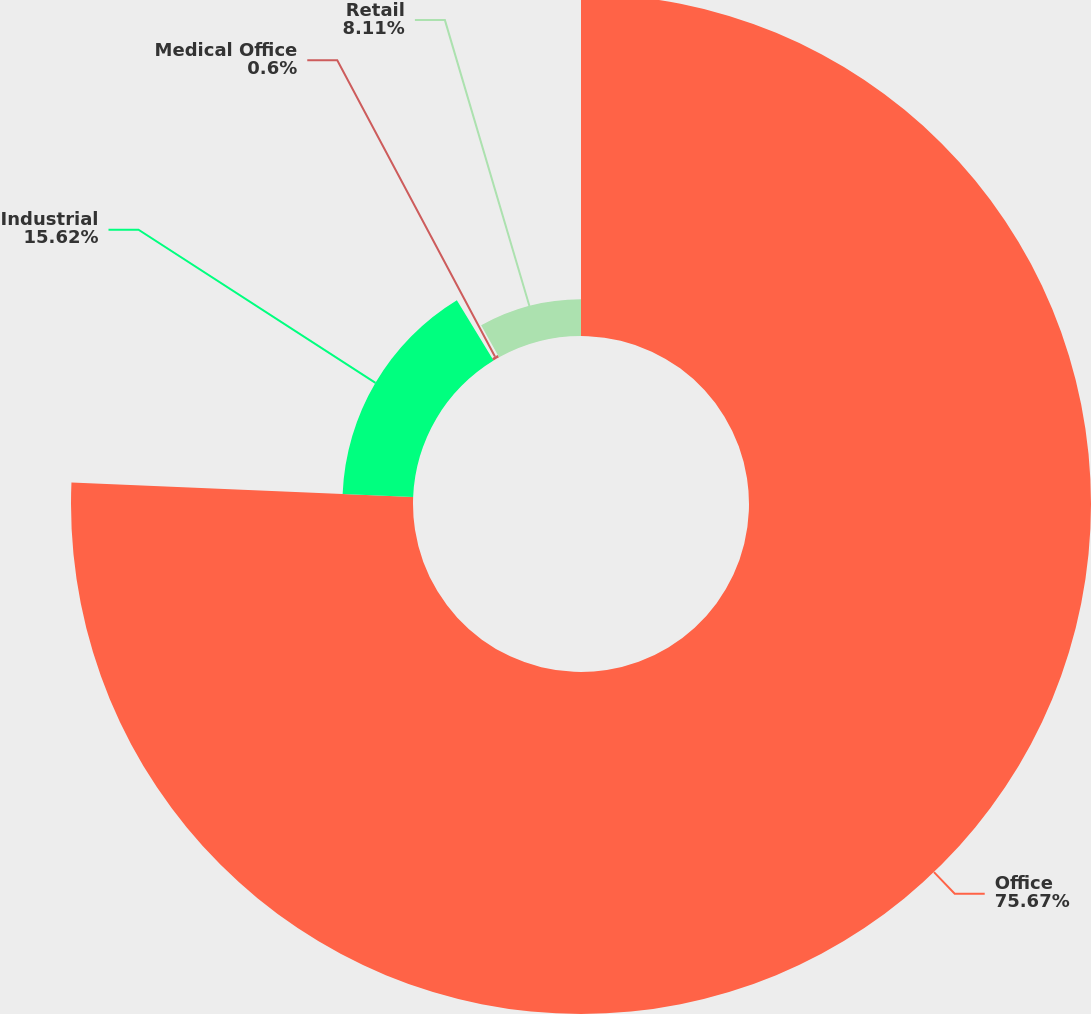Convert chart to OTSL. <chart><loc_0><loc_0><loc_500><loc_500><pie_chart><fcel>Office<fcel>Industrial<fcel>Medical Office<fcel>Retail<nl><fcel>75.67%<fcel>15.62%<fcel>0.6%<fcel>8.11%<nl></chart> 